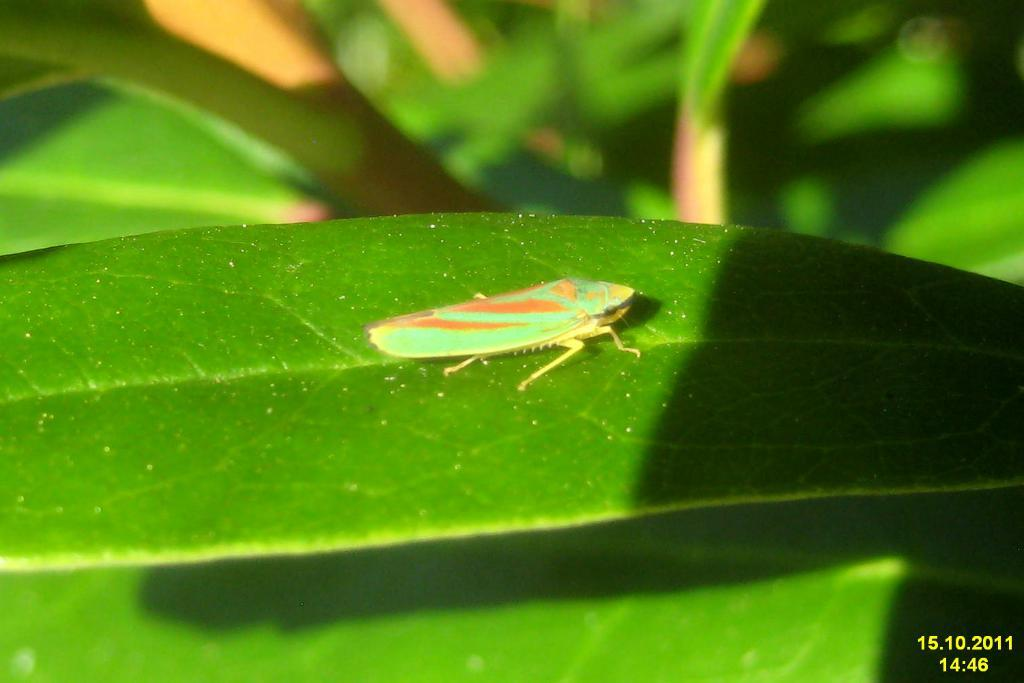What insect is present in the image? There is a leafhopper in the image. Where is the leafhopper located? The leafhopper is on a leaf. What type of shoes is the leafhopper wearing in the image? The leafhopper is not wearing shoes, as it is an insect and does not wear clothing or accessories. 